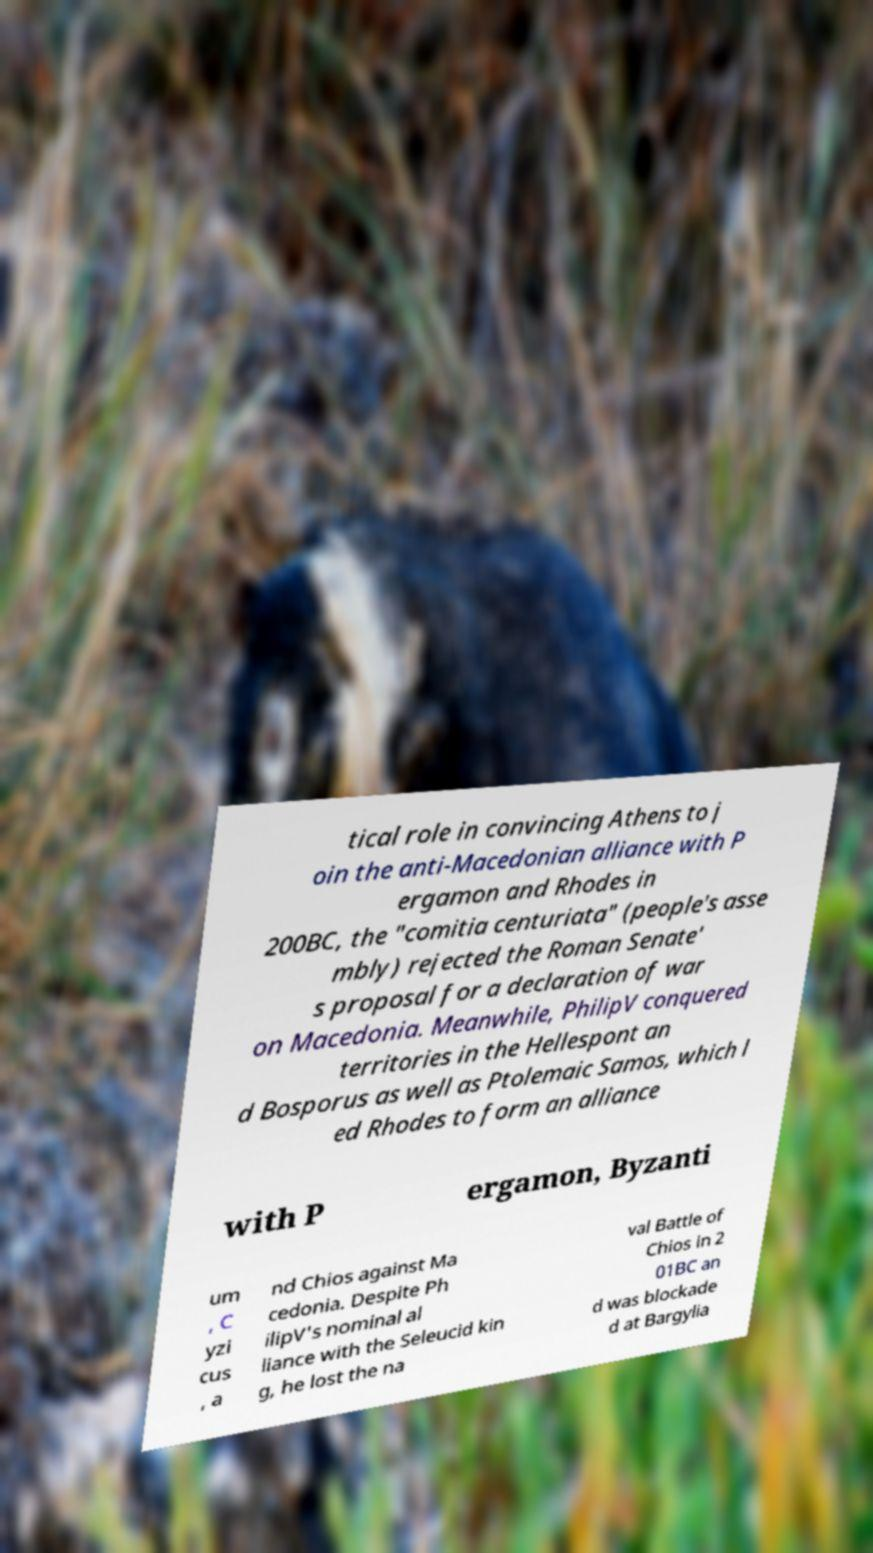Please identify and transcribe the text found in this image. tical role in convincing Athens to j oin the anti-Macedonian alliance with P ergamon and Rhodes in 200BC, the "comitia centuriata" (people's asse mbly) rejected the Roman Senate' s proposal for a declaration of war on Macedonia. Meanwhile, PhilipV conquered territories in the Hellespont an d Bosporus as well as Ptolemaic Samos, which l ed Rhodes to form an alliance with P ergamon, Byzanti um , C yzi cus , a nd Chios against Ma cedonia. Despite Ph ilipV's nominal al liance with the Seleucid kin g, he lost the na val Battle of Chios in 2 01BC an d was blockade d at Bargylia 